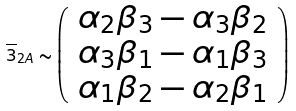<formula> <loc_0><loc_0><loc_500><loc_500>\overline { 3 } _ { 2 A } \sim \left ( \begin{array} { c } \alpha _ { 2 } \beta _ { 3 } - \alpha _ { 3 } \beta _ { 2 } \\ \alpha _ { 3 } \beta _ { 1 } - \alpha _ { 1 } \beta _ { 3 } \\ \alpha _ { 1 } \beta _ { 2 } - \alpha _ { 2 } \beta _ { 1 } \\ \end{array} \right )</formula> 